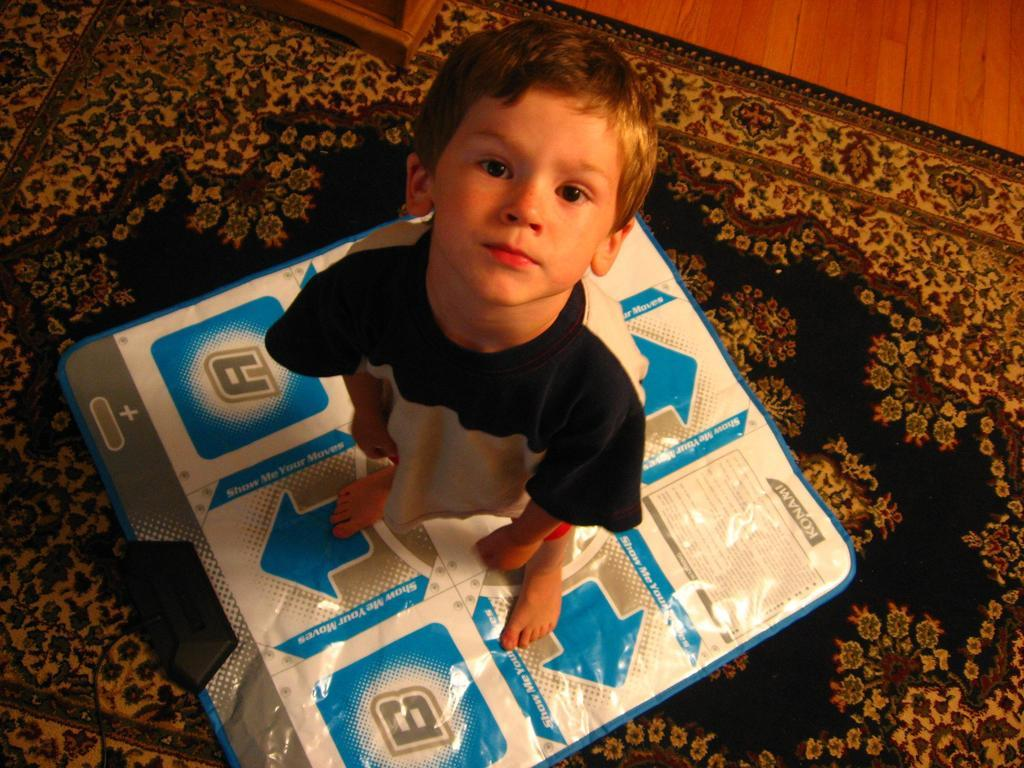What is the main subject of the image? The main subject of the image is a boy. What is the boy standing on? The boy is standing on a cover. What type of flooring is visible at the bottom of the image? There is a carpet at the bottom of the image. How many branches can be seen growing from the bomb in the image? There is no bomb present in the image, and therefore no branches can be seen growing from it. 